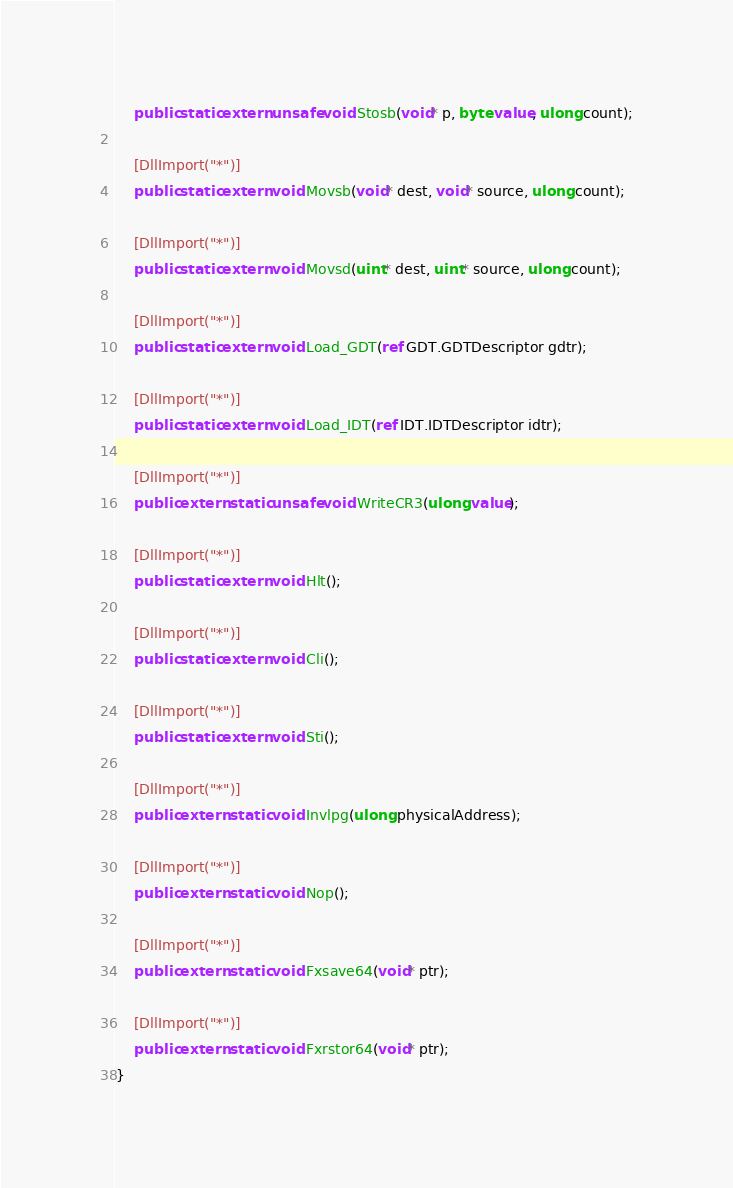Convert code to text. <code><loc_0><loc_0><loc_500><loc_500><_C#_>    public static extern unsafe void Stosb(void* p, byte value, ulong count);

    [DllImport("*")]
    public static extern void Movsb(void* dest, void* source, ulong count);

    [DllImport("*")]
    public static extern void Movsd(uint* dest, uint* source, ulong count);

    [DllImport("*")]
    public static extern void Load_GDT(ref GDT.GDTDescriptor gdtr);

    [DllImport("*")]
    public static extern void Load_IDT(ref IDT.IDTDescriptor idtr);

    [DllImport("*")]
    public extern static unsafe void WriteCR3(ulong value);

    [DllImport("*")]
    public static extern void Hlt();

    [DllImport("*")]
    public static extern void Cli();

    [DllImport("*")]
    public static extern void Sti();

    [DllImport("*")]
    public extern static void Invlpg(ulong physicalAddress);

    [DllImport("*")]
    public extern static void Nop();

    [DllImport("*")]
    public extern static void Fxsave64(void* ptr);

    [DllImport("*")]
    public extern static void Fxrstor64(void* ptr);
}</code> 